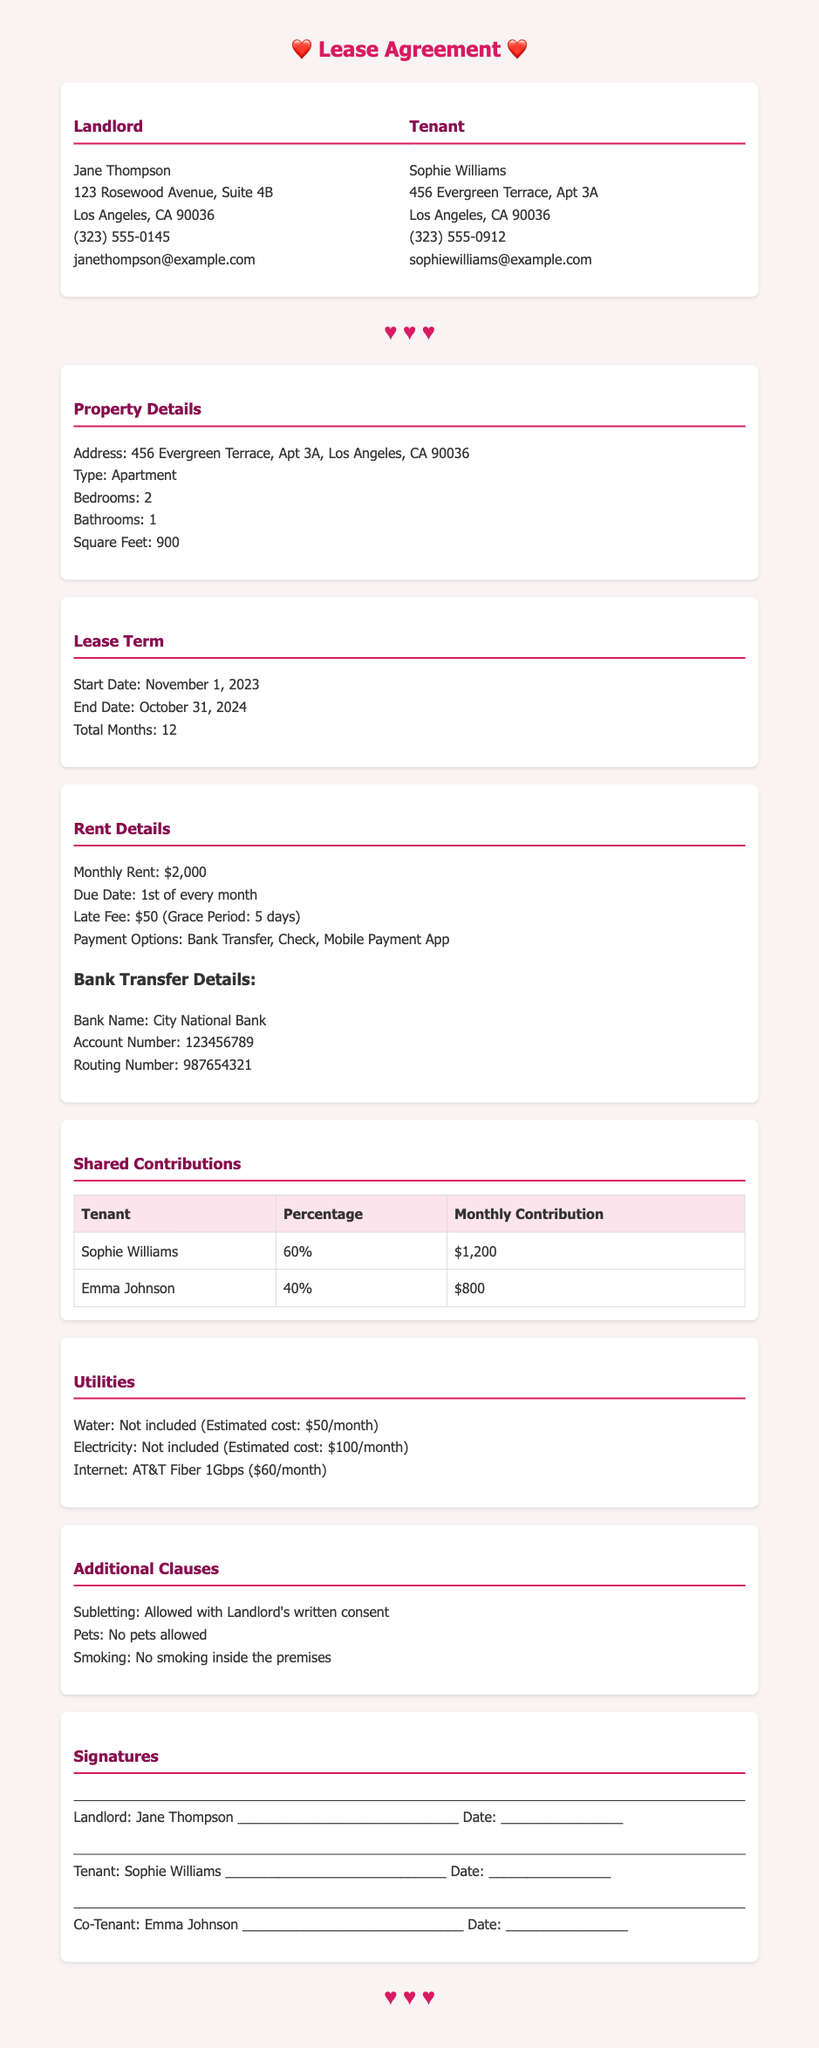What is the monthly rent? The monthly rent is stated clearly in the Rent Details section of the document.
Answer: $2,000 When is the rent payment due? The due date for rent is specified in the Rent Details section.
Answer: 1st of every month What percentage of rent does Sophie contribute? This percentage is found in the Shared Contributions table under Sophie's entry.
Answer: 60% What is the late fee if the rent is paid late? The late fee amount is mentioned in the Rent Details section of the document.
Answer: $50 Who is the Landlord? The name of the landlord is provided in the party information section of the document.
Answer: Jane Thompson What utility is not included in the rent and has an estimated cost of $50 per month? The information about inclusions and estimated costs are listed in the Utilities section.
Answer: Water What is the start date of the lease? The start date can be found in the Lease Term section, clearly indicating when the lease begins.
Answer: November 1, 2023 Which payment options are available for rent? The available payment methods are listed in the Rent Details section.
Answer: Bank Transfer, Check, Mobile Payment App Is smoking allowed inside the premises? This is specified under the Additional Clauses section regarding smoking rules.
Answer: No 